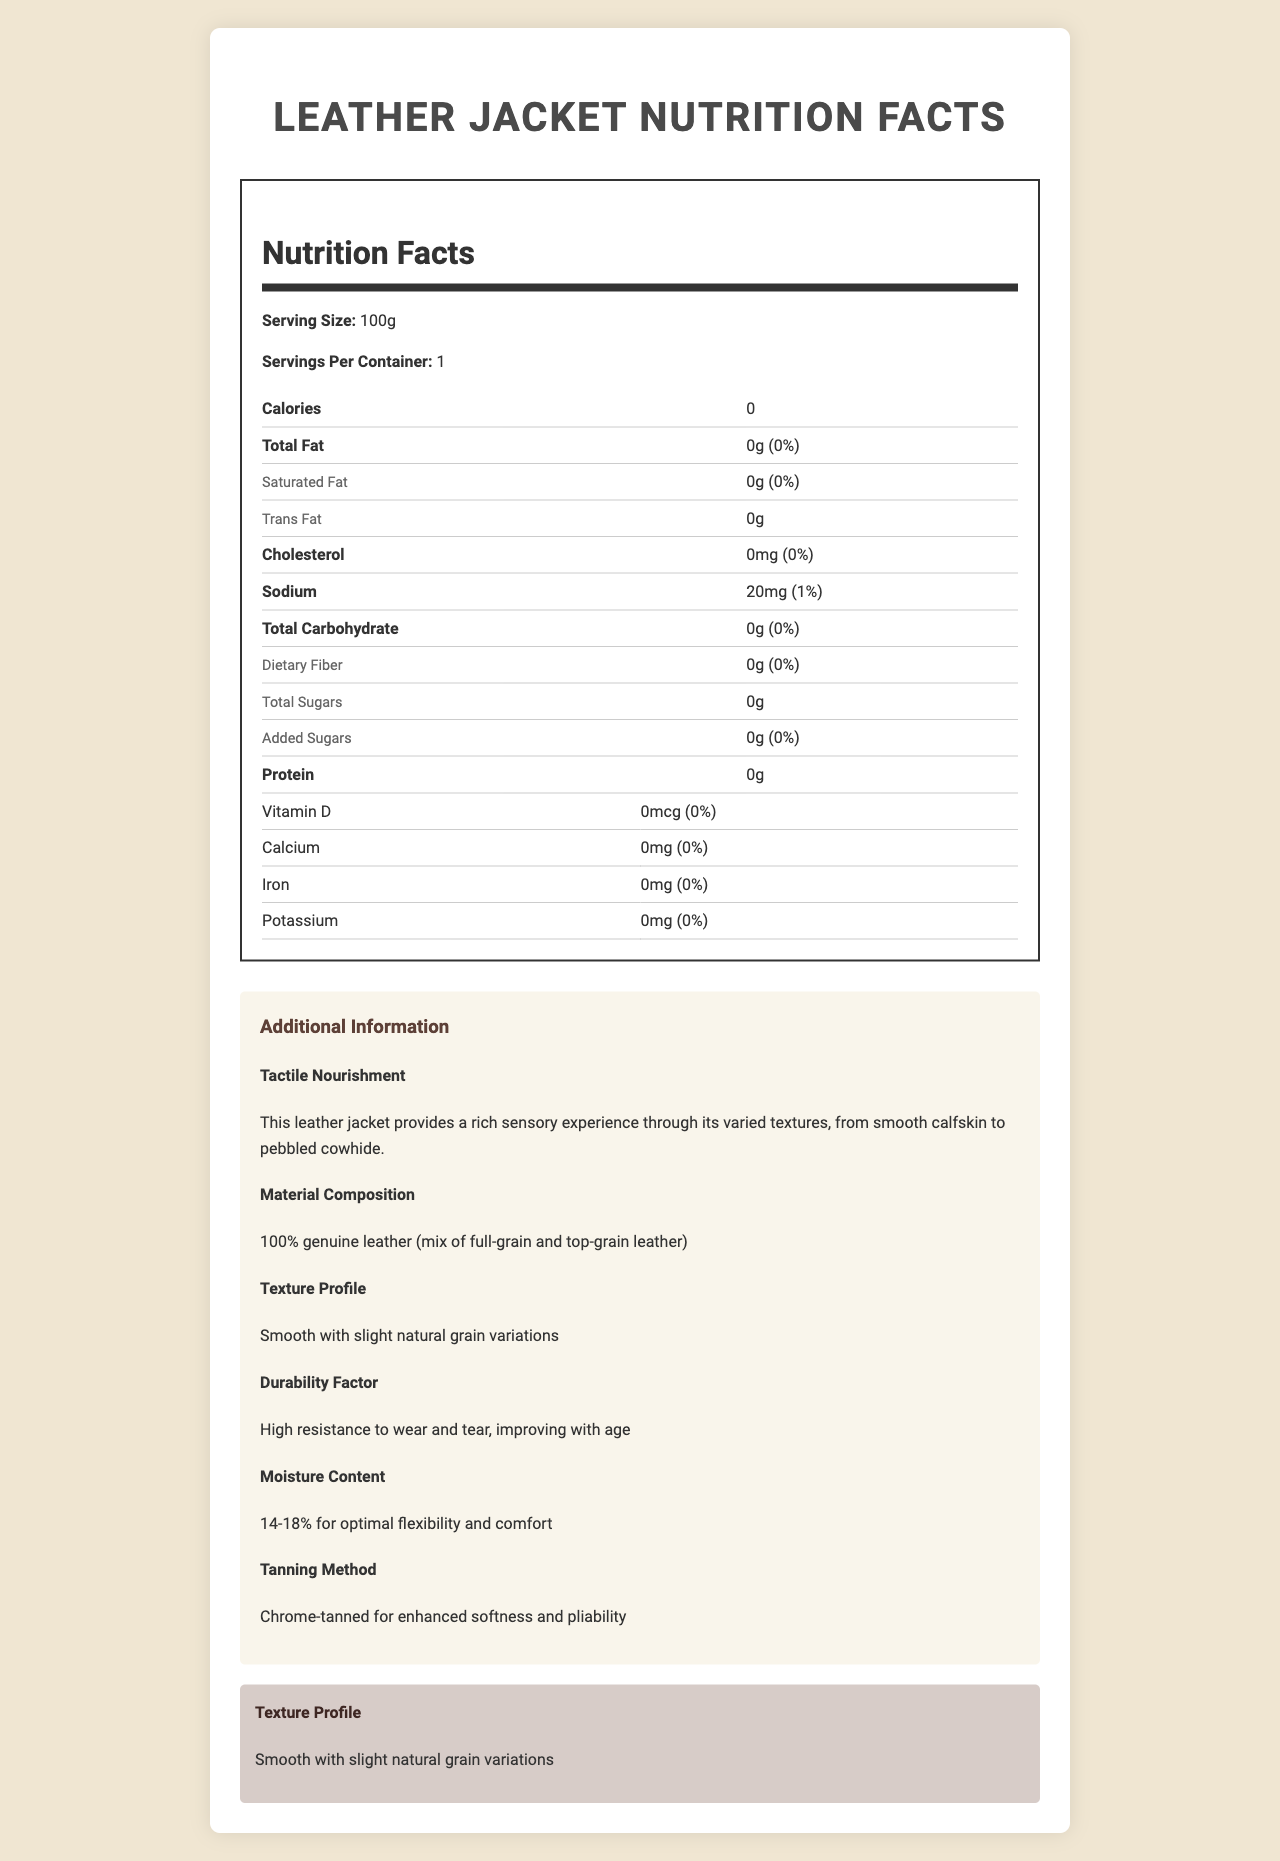what is the serving size for this leather jacket? The serving size is explicitly mentioned at the top of the nutrition label.
Answer: 100g how much total fat does the leather jacket contain? The total fat content is listed as "0g" on the nutrition label.
Answer: 0g is there any cholesterol in the leather jacket? Cholesterol content is shown as "0mg" with a daily value of "0%."
Answer: No What percentage of the daily value is the saturated fat content? The saturated fat content shows "0g" and "0%" for its daily value.
Answer: 0% What is the moisture content mentioned in the additional information? The additional information section specifies a "Moisture Content" of "14-18%."
Answer: 14-18% How many calories are in the leather jacket? A. 100 B. 50 C. 0 D. 200 The nutrition label lists the calories per serving as "0."
Answer: C Which of the following textures is highlighted in the document? A. Smooth Calfskin B. Pebbled Cowhide C. Both D. Neither The additional information mentions that the jacket provides textures from both "smooth calfskin" and "pebbled cowhide."
Answer: C Is there any iron content in the leather jacket? The nutrition label lists the iron content as "0mg" with a daily value of "0%."
Answer: No Summarize the key points of the document. The document is a nutritional label for a leather jacket which highlights that the jacket's nutritional values (such as calories, fats, and cholesterol) are zero. Additionally, it includes information about the texture, durability, and composition of the leather, emphasizing the tactile nourishment and high resistance to wear and tear.
Answer: The document presents the nutritional information for a leather jacket, emphasizing that it contains no calories, fat, cholesterol, carbohydrates, or protein. It also provides extensive details about the texture, material composition, and durability of the jacket. The focus is on the sensory experience and quality of the leather. What is the total carbohydrate content in the leather jacket? The nutrition label shows that the total carbohydrate content is "0g."
Answer: 0g Can the type of leather used in the jacket be determined from the document? The additional information specifies that the jacket is made from a mix of full-grain and top-grain leather.
Answer: Yes What is the primary tanning method used for this leather jacket? The additional information states that the leather is "chrome-tanned for enhanced softness and pliability."
Answer: Chrome-tanned Does the document mention the vitamin D content in the leather jacket? The nutrition label mentions that the vitamin D content is "0mcg" with a percent daily value of "0%."
Answer: Yes Which nutrient has the highest daily value percentage mentioned in the document? The sodium content is shown with a daily value of "1%," which is the highest among all nutrients listed.
Answer: Sodium What is the durability factor of this leather jacket? The additional information section mentions that the jacket has "high resistance to wear and tear, improving with age."
Answer: High resistance to wear and tear, improving with age Does the document provide any information about the flexibility and comfort of the leather? The additional information states that the moisture content is "14-18% for optimal flexibility and comfort."
Answer: Yes Can the exact color of the leather jacket be determined from the document? The document does not provide any information regarding the color of the leather jacket.
Answer: Not enough information 